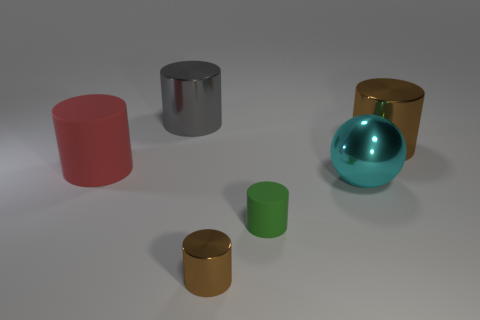Are there any other things that have the same shape as the big red thing?
Your answer should be very brief. Yes. Is there a brown metal cylinder behind the matte cylinder to the right of the large gray metal cylinder?
Ensure brevity in your answer.  Yes. What is the color of the small metal thing that is the same shape as the big red matte thing?
Offer a very short reply. Brown. How many cylinders are the same color as the small shiny object?
Keep it short and to the point. 1. There is a big shiny cylinder that is left of the brown object that is in front of the big object that is to the right of the sphere; what is its color?
Provide a succinct answer. Gray. Are the large cyan ball and the large gray cylinder made of the same material?
Give a very brief answer. Yes. Does the gray shiny object have the same shape as the cyan metal thing?
Make the answer very short. No. Are there an equal number of cyan metal objects that are left of the gray metallic object and cyan shiny objects left of the tiny shiny object?
Your response must be concise. Yes. What is the color of the tiny cylinder that is the same material as the big red object?
Offer a very short reply. Green. What number of big purple spheres are the same material as the small brown cylinder?
Your response must be concise. 0. 